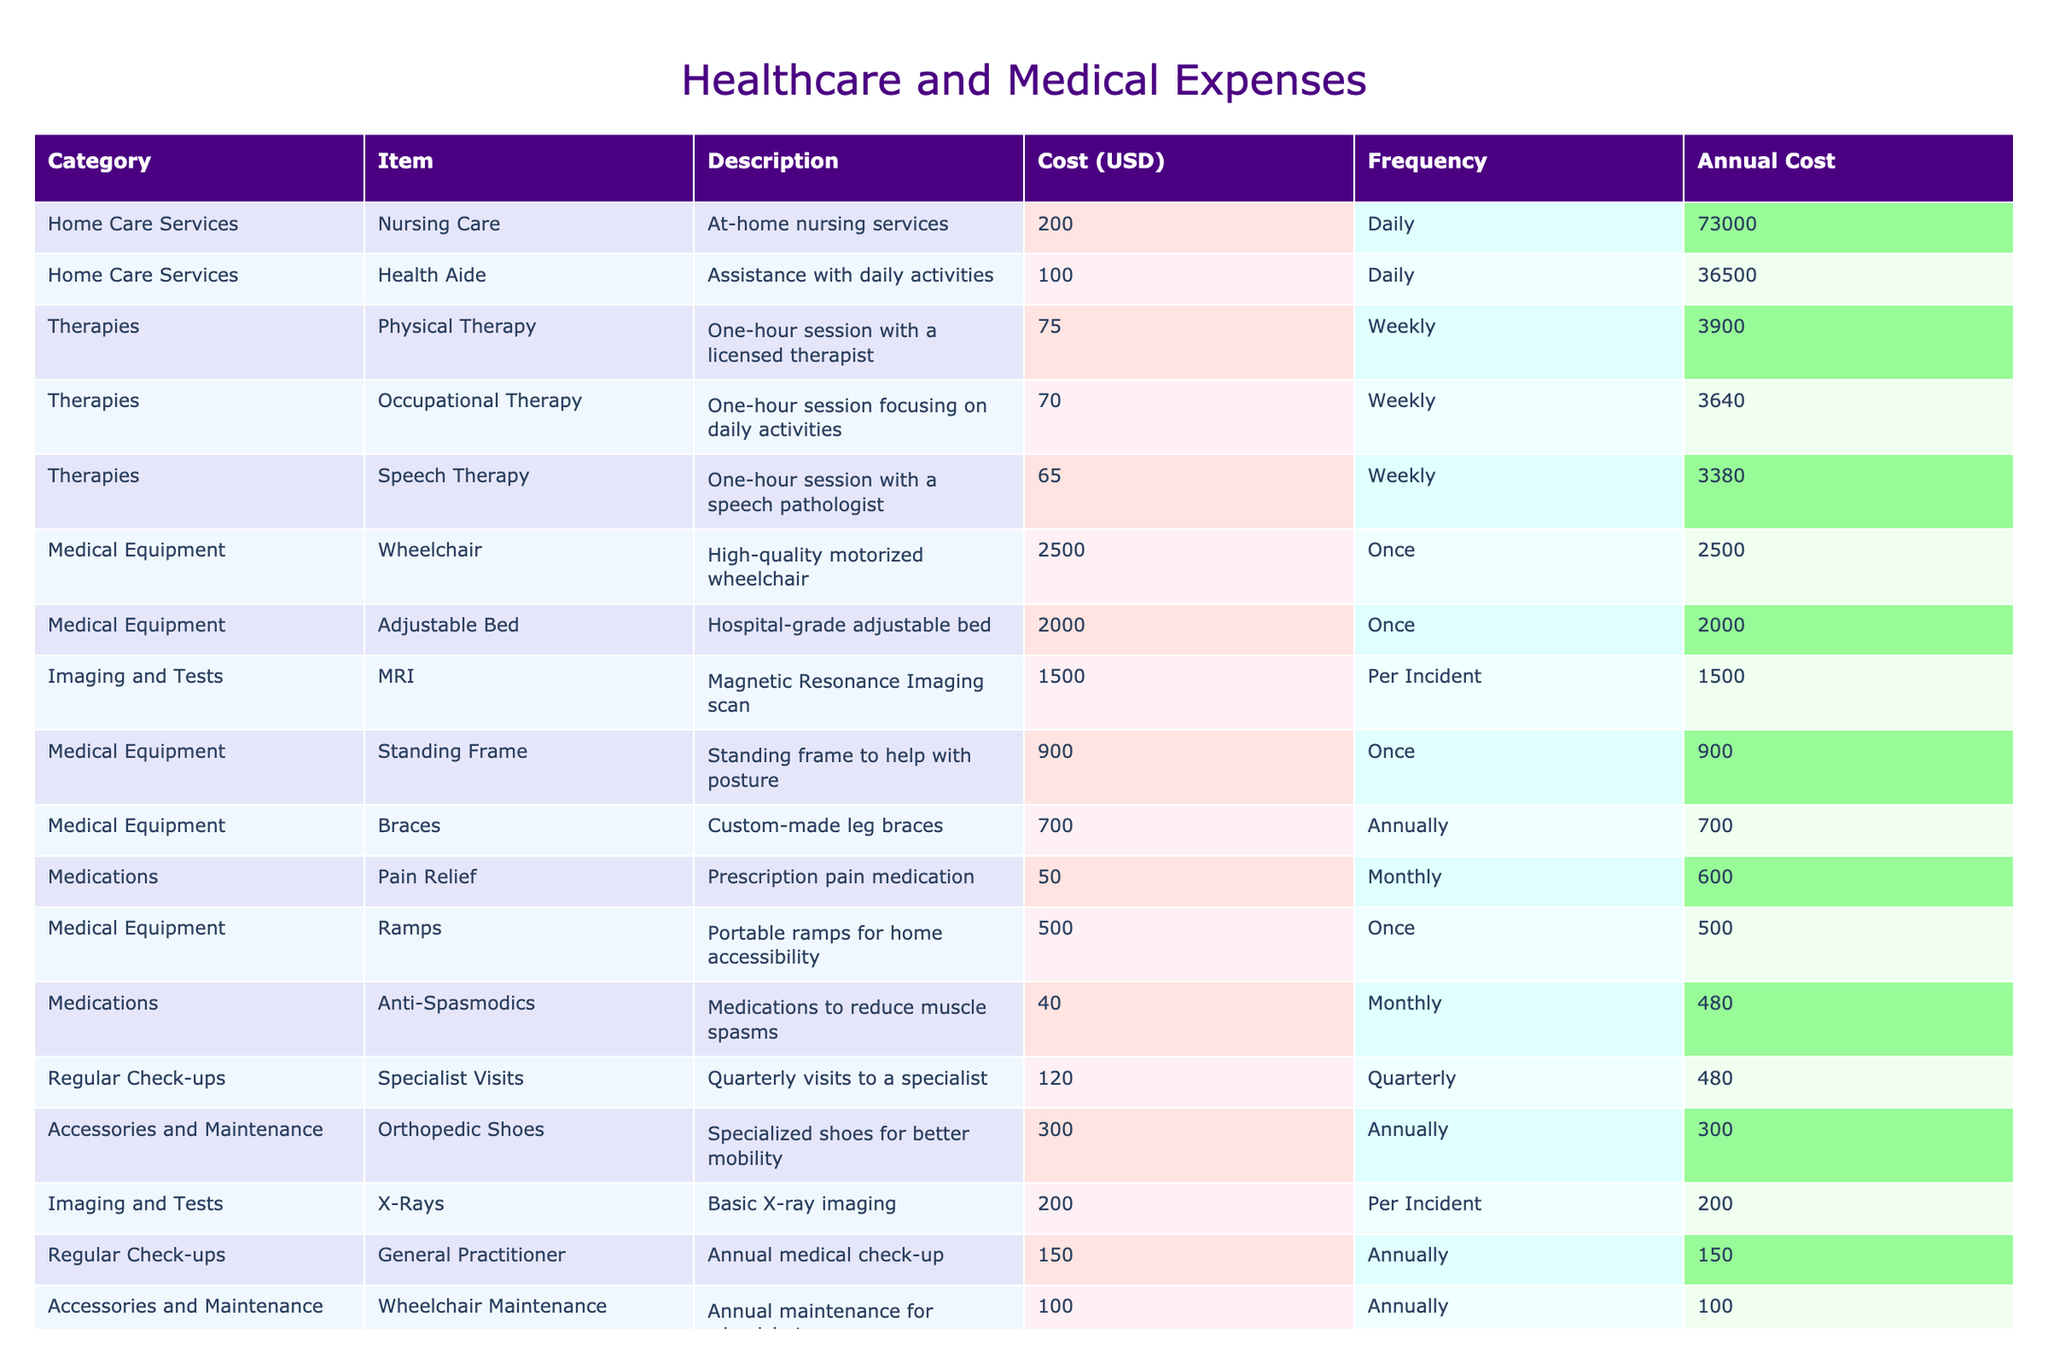What is the cost of a wheelchair? The table lists a wheelchair under the "Medical Equipment" category, with a cost of 2500 USD.
Answer: 2500 USD How much does occupational therapy cost annually? Occupational therapy costs 70 USD per session and is billed weekly. To find the annual cost, multiply 70 by 52 (the number of weeks in a year), which results in 3640 USD.
Answer: 3640 USD Are braces custom-made? The table indicates that braces are custom-made leg braces, confirming that they are tailored specifically for individual needs.
Answer: Yes What is the total annual cost of all medications? The medications' costs are: Pain Relief (50 USD monthly), Anti-Spasmodics (40 USD monthly), and Antibiotics (30 USD per incident). For annual costs, Pain Relief costs 600 USD (50 USD * 12), Anti-Spasmodics costs 480 USD (40 USD * 12), and we need to consider antibiotics as a variable cost. Adding the annual medication costs (600 + 480) gives 1080 USD. Antibiotics do not have a fixed cost as it depends on incidents, so total cannot be definitively ascertained but can be at least 1080 USD.
Answer: At least 1080 USD What is the frequency of general practitioner check-ups? The table states that general practitioner check-ups occur annually, indicating that one visit is made each year.
Answer: Annually How much do you spend annually on regular check-ups? The regular check-ups include: General Practitioner at 150 USD annually and Specialist Visits at 120 USD quarterly. The specialist requires 120 * 4 = 480 USD annually. Therefore, the total annual spending on check-ups is 150 + 480, equaling 630 USD.
Answer: 630 USD Is the cost of a standing frame less than the cost of an adjustable bed? The standing frame costs 900 USD and the adjustable bed costs 2000 USD. Since 900 is less than 2000, the standing frame is indeed cheaper.
Answer: Yes What is the total cost for daily home care services over one year? Nursing care costs 200 USD daily, and health aide costs 100 USD daily. The total cost for both services per day is 200 + 100 = 300 USD. Over a year (365 days), the cost is 300 * 365 = 109500 USD.
Answer: 109500 USD 